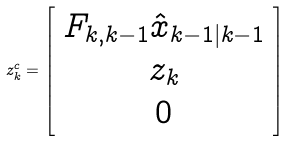Convert formula to latex. <formula><loc_0><loc_0><loc_500><loc_500>z _ { k } ^ { c } = \left [ \begin{array} { c } F _ { k , k - 1 } \hat { x } _ { k - 1 | k - 1 } \\ z _ { k } \\ 0 \end{array} \right ]</formula> 